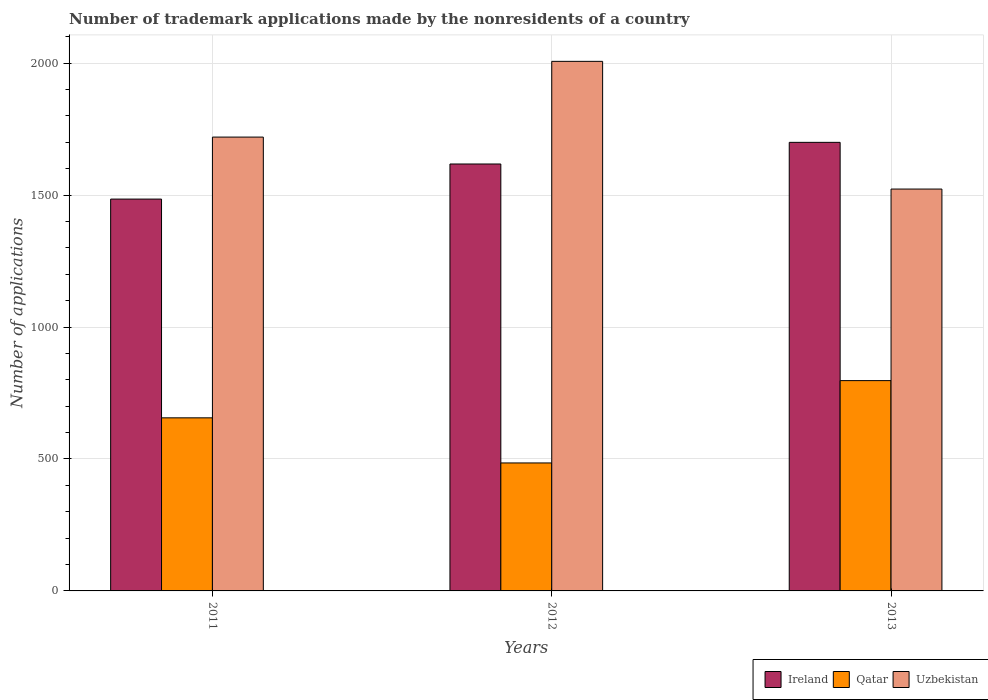How many different coloured bars are there?
Your answer should be compact. 3. How many groups of bars are there?
Ensure brevity in your answer.  3. Are the number of bars on each tick of the X-axis equal?
Give a very brief answer. Yes. How many bars are there on the 3rd tick from the right?
Offer a terse response. 3. What is the label of the 2nd group of bars from the left?
Offer a very short reply. 2012. What is the number of trademark applications made by the nonresidents in Qatar in 2013?
Provide a succinct answer. 797. Across all years, what is the maximum number of trademark applications made by the nonresidents in Uzbekistan?
Give a very brief answer. 2007. Across all years, what is the minimum number of trademark applications made by the nonresidents in Uzbekistan?
Your response must be concise. 1523. In which year was the number of trademark applications made by the nonresidents in Qatar minimum?
Provide a short and direct response. 2012. What is the total number of trademark applications made by the nonresidents in Ireland in the graph?
Offer a very short reply. 4803. What is the difference between the number of trademark applications made by the nonresidents in Ireland in 2011 and that in 2012?
Your answer should be compact. -133. What is the difference between the number of trademark applications made by the nonresidents in Uzbekistan in 2012 and the number of trademark applications made by the nonresidents in Qatar in 2013?
Your answer should be compact. 1210. What is the average number of trademark applications made by the nonresidents in Ireland per year?
Provide a short and direct response. 1601. In the year 2013, what is the difference between the number of trademark applications made by the nonresidents in Ireland and number of trademark applications made by the nonresidents in Uzbekistan?
Provide a succinct answer. 177. In how many years, is the number of trademark applications made by the nonresidents in Ireland greater than 500?
Your response must be concise. 3. What is the ratio of the number of trademark applications made by the nonresidents in Uzbekistan in 2012 to that in 2013?
Keep it short and to the point. 1.32. Is the number of trademark applications made by the nonresidents in Ireland in 2011 less than that in 2013?
Ensure brevity in your answer.  Yes. What is the difference between the highest and the second highest number of trademark applications made by the nonresidents in Uzbekistan?
Offer a very short reply. 287. What is the difference between the highest and the lowest number of trademark applications made by the nonresidents in Ireland?
Offer a terse response. 215. In how many years, is the number of trademark applications made by the nonresidents in Qatar greater than the average number of trademark applications made by the nonresidents in Qatar taken over all years?
Provide a succinct answer. 2. What does the 2nd bar from the left in 2013 represents?
Give a very brief answer. Qatar. What does the 1st bar from the right in 2012 represents?
Provide a short and direct response. Uzbekistan. How many bars are there?
Ensure brevity in your answer.  9. How many years are there in the graph?
Your response must be concise. 3. Are the values on the major ticks of Y-axis written in scientific E-notation?
Make the answer very short. No. Does the graph contain grids?
Provide a short and direct response. Yes. How are the legend labels stacked?
Make the answer very short. Horizontal. What is the title of the graph?
Offer a terse response. Number of trademark applications made by the nonresidents of a country. Does "South Sudan" appear as one of the legend labels in the graph?
Your answer should be compact. No. What is the label or title of the Y-axis?
Give a very brief answer. Number of applications. What is the Number of applications of Ireland in 2011?
Keep it short and to the point. 1485. What is the Number of applications of Qatar in 2011?
Your answer should be very brief. 656. What is the Number of applications in Uzbekistan in 2011?
Offer a terse response. 1720. What is the Number of applications in Ireland in 2012?
Keep it short and to the point. 1618. What is the Number of applications of Qatar in 2012?
Make the answer very short. 485. What is the Number of applications in Uzbekistan in 2012?
Keep it short and to the point. 2007. What is the Number of applications of Ireland in 2013?
Provide a short and direct response. 1700. What is the Number of applications of Qatar in 2013?
Your answer should be compact. 797. What is the Number of applications of Uzbekistan in 2013?
Keep it short and to the point. 1523. Across all years, what is the maximum Number of applications of Ireland?
Offer a very short reply. 1700. Across all years, what is the maximum Number of applications in Qatar?
Keep it short and to the point. 797. Across all years, what is the maximum Number of applications of Uzbekistan?
Your answer should be very brief. 2007. Across all years, what is the minimum Number of applications in Ireland?
Offer a terse response. 1485. Across all years, what is the minimum Number of applications in Qatar?
Your response must be concise. 485. Across all years, what is the minimum Number of applications of Uzbekistan?
Offer a very short reply. 1523. What is the total Number of applications of Ireland in the graph?
Provide a short and direct response. 4803. What is the total Number of applications in Qatar in the graph?
Your response must be concise. 1938. What is the total Number of applications of Uzbekistan in the graph?
Make the answer very short. 5250. What is the difference between the Number of applications in Ireland in 2011 and that in 2012?
Provide a succinct answer. -133. What is the difference between the Number of applications of Qatar in 2011 and that in 2012?
Your answer should be very brief. 171. What is the difference between the Number of applications of Uzbekistan in 2011 and that in 2012?
Your response must be concise. -287. What is the difference between the Number of applications in Ireland in 2011 and that in 2013?
Make the answer very short. -215. What is the difference between the Number of applications of Qatar in 2011 and that in 2013?
Offer a terse response. -141. What is the difference between the Number of applications of Uzbekistan in 2011 and that in 2013?
Ensure brevity in your answer.  197. What is the difference between the Number of applications in Ireland in 2012 and that in 2013?
Keep it short and to the point. -82. What is the difference between the Number of applications in Qatar in 2012 and that in 2013?
Ensure brevity in your answer.  -312. What is the difference between the Number of applications in Uzbekistan in 2012 and that in 2013?
Provide a short and direct response. 484. What is the difference between the Number of applications in Ireland in 2011 and the Number of applications in Uzbekistan in 2012?
Your answer should be compact. -522. What is the difference between the Number of applications of Qatar in 2011 and the Number of applications of Uzbekistan in 2012?
Provide a short and direct response. -1351. What is the difference between the Number of applications in Ireland in 2011 and the Number of applications in Qatar in 2013?
Offer a terse response. 688. What is the difference between the Number of applications of Ireland in 2011 and the Number of applications of Uzbekistan in 2013?
Provide a short and direct response. -38. What is the difference between the Number of applications in Qatar in 2011 and the Number of applications in Uzbekistan in 2013?
Give a very brief answer. -867. What is the difference between the Number of applications in Ireland in 2012 and the Number of applications in Qatar in 2013?
Provide a succinct answer. 821. What is the difference between the Number of applications of Ireland in 2012 and the Number of applications of Uzbekistan in 2013?
Provide a succinct answer. 95. What is the difference between the Number of applications of Qatar in 2012 and the Number of applications of Uzbekistan in 2013?
Give a very brief answer. -1038. What is the average Number of applications in Ireland per year?
Provide a short and direct response. 1601. What is the average Number of applications of Qatar per year?
Ensure brevity in your answer.  646. What is the average Number of applications in Uzbekistan per year?
Offer a terse response. 1750. In the year 2011, what is the difference between the Number of applications in Ireland and Number of applications in Qatar?
Ensure brevity in your answer.  829. In the year 2011, what is the difference between the Number of applications of Ireland and Number of applications of Uzbekistan?
Provide a succinct answer. -235. In the year 2011, what is the difference between the Number of applications of Qatar and Number of applications of Uzbekistan?
Your answer should be compact. -1064. In the year 2012, what is the difference between the Number of applications in Ireland and Number of applications in Qatar?
Your answer should be compact. 1133. In the year 2012, what is the difference between the Number of applications of Ireland and Number of applications of Uzbekistan?
Provide a short and direct response. -389. In the year 2012, what is the difference between the Number of applications of Qatar and Number of applications of Uzbekistan?
Offer a terse response. -1522. In the year 2013, what is the difference between the Number of applications in Ireland and Number of applications in Qatar?
Provide a short and direct response. 903. In the year 2013, what is the difference between the Number of applications of Ireland and Number of applications of Uzbekistan?
Your answer should be compact. 177. In the year 2013, what is the difference between the Number of applications in Qatar and Number of applications in Uzbekistan?
Your answer should be compact. -726. What is the ratio of the Number of applications in Ireland in 2011 to that in 2012?
Offer a very short reply. 0.92. What is the ratio of the Number of applications of Qatar in 2011 to that in 2012?
Offer a very short reply. 1.35. What is the ratio of the Number of applications in Uzbekistan in 2011 to that in 2012?
Offer a very short reply. 0.86. What is the ratio of the Number of applications of Ireland in 2011 to that in 2013?
Keep it short and to the point. 0.87. What is the ratio of the Number of applications of Qatar in 2011 to that in 2013?
Ensure brevity in your answer.  0.82. What is the ratio of the Number of applications of Uzbekistan in 2011 to that in 2013?
Keep it short and to the point. 1.13. What is the ratio of the Number of applications in Ireland in 2012 to that in 2013?
Keep it short and to the point. 0.95. What is the ratio of the Number of applications in Qatar in 2012 to that in 2013?
Offer a very short reply. 0.61. What is the ratio of the Number of applications in Uzbekistan in 2012 to that in 2013?
Provide a short and direct response. 1.32. What is the difference between the highest and the second highest Number of applications in Ireland?
Ensure brevity in your answer.  82. What is the difference between the highest and the second highest Number of applications in Qatar?
Provide a succinct answer. 141. What is the difference between the highest and the second highest Number of applications in Uzbekistan?
Offer a very short reply. 287. What is the difference between the highest and the lowest Number of applications in Ireland?
Provide a short and direct response. 215. What is the difference between the highest and the lowest Number of applications of Qatar?
Provide a short and direct response. 312. What is the difference between the highest and the lowest Number of applications of Uzbekistan?
Offer a very short reply. 484. 